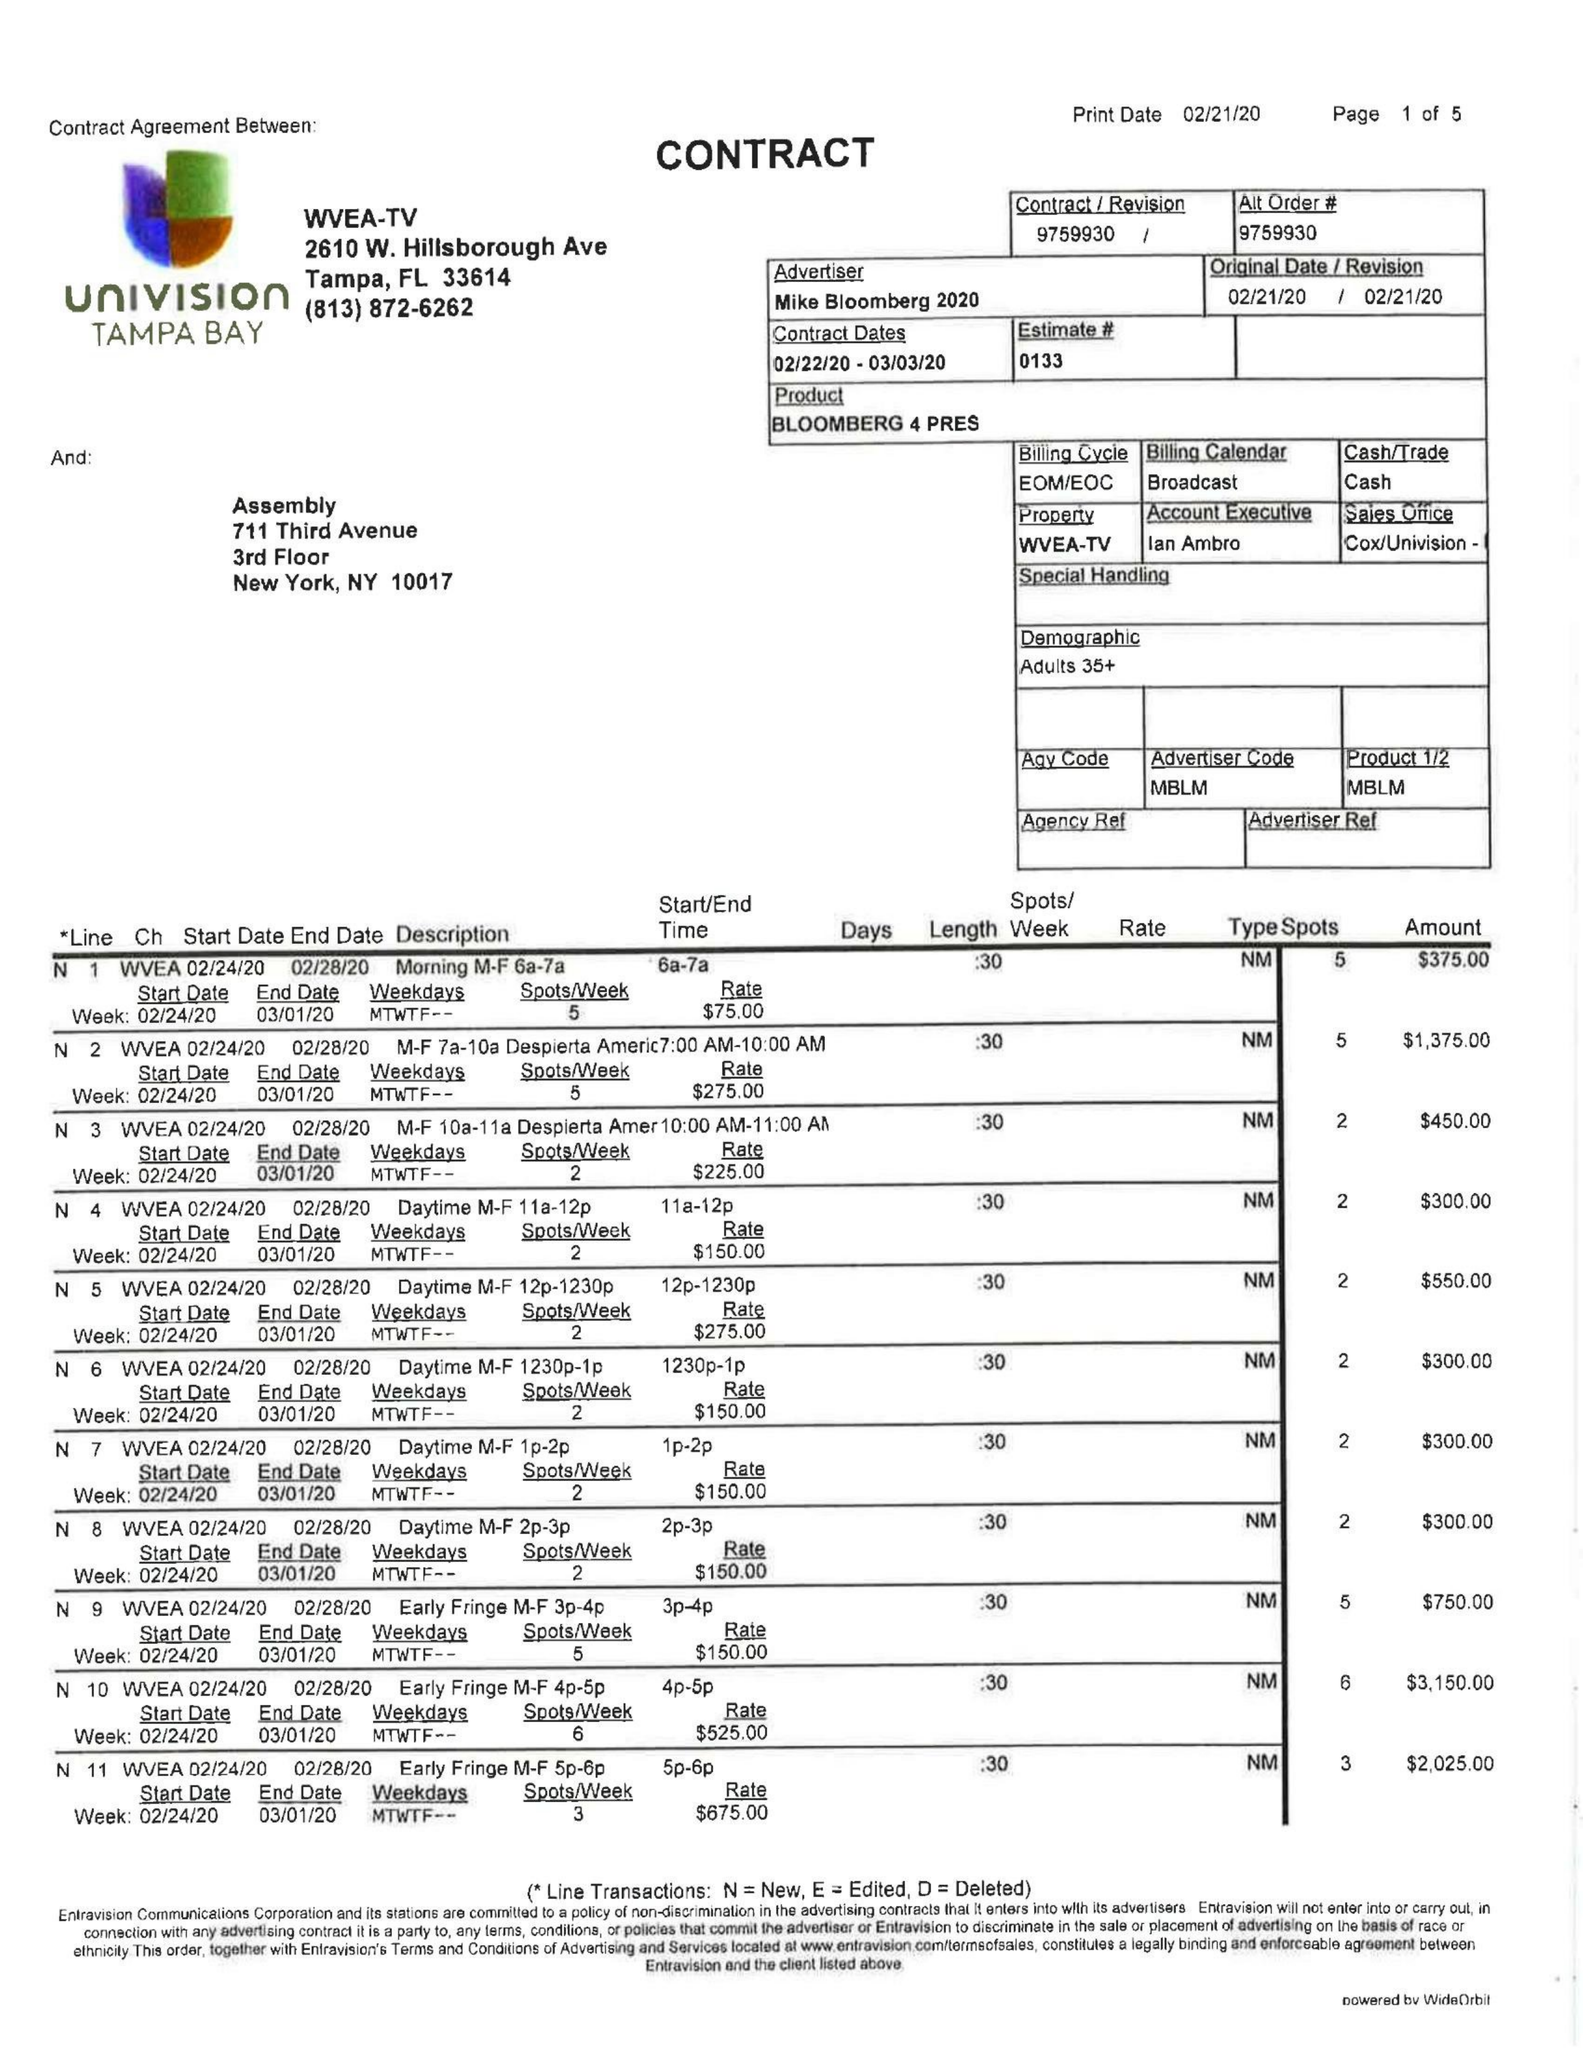What is the value for the advertiser?
Answer the question using a single word or phrase. MIKE BLOOMBERG 2020 